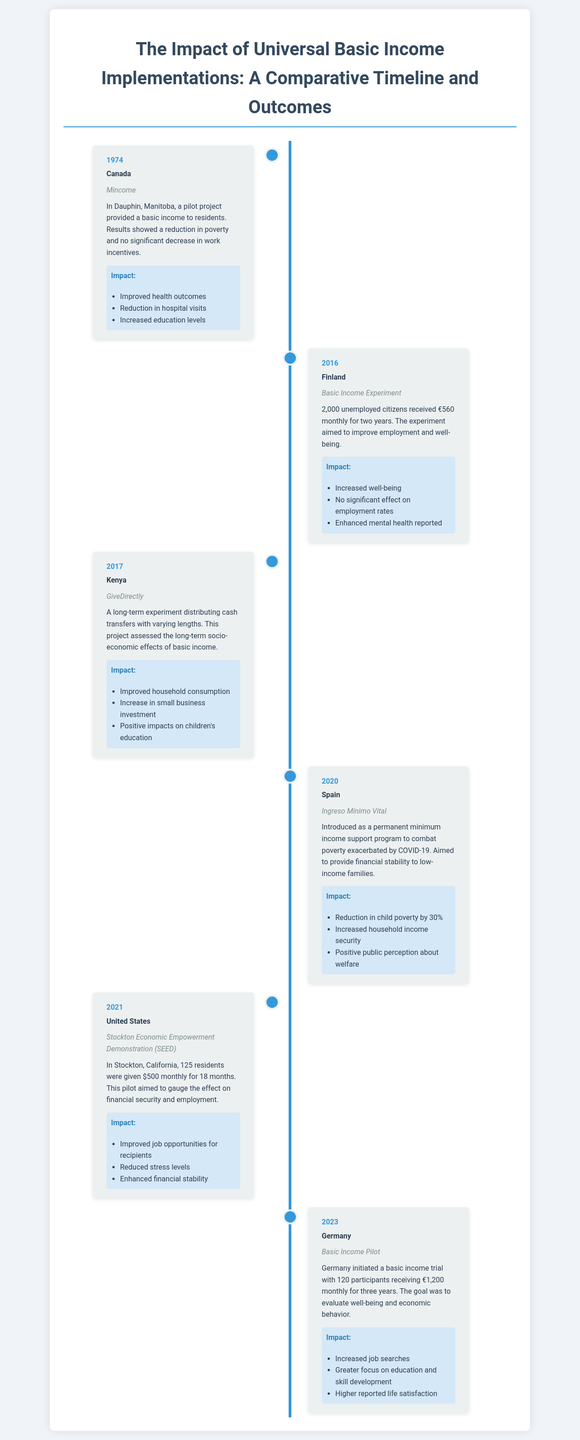what year did Canada implement the Mincome experiment? The document states that the Mincome pilot project was conducted in Canada in 1974.
Answer: 1974 which country conducted the Basic Income Experiment in 2016? According to the document, Finland implemented the Basic Income Experiment in 2016.
Answer: Finland what was the amount received monthly by participants in the Stockton Economic Empowerment Demonstration? The document mentions that participants in this demonstration received $500 monthly.
Answer: $500 what was the reduction in child poverty achieved by Spain's Ingreso Mínimo Vital? The document indicates that Spain's program led to a reduction in child poverty by 30%.
Answer: 30% list one impact of the GiveDirectly experiment in Kenya. The document provides several impacts, one of which is the improvement in household consumption.
Answer: Improved household consumption which country initiated a basic income trial with 120 participants in 2023? As per the document, Germany initiated this basic income trial in 2023.
Answer: Germany was there a significant effect on employment rates in Finland's Basic Income Experiment? The document states that there was no significant effect on employment rates from this experiment.
Answer: No what percentage of increased household income security was reported due to Spain's program? The document notes that Spain's Ingreso Mínimo Vital increased household income security, but it does not specify a percentage.
Answer: Not specified 